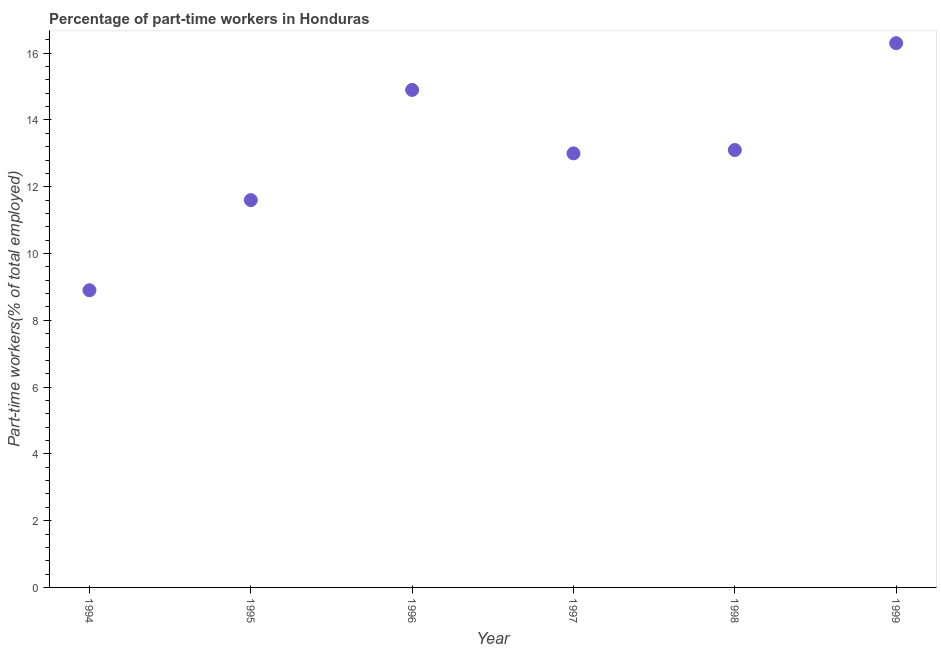What is the percentage of part-time workers in 1994?
Give a very brief answer. 8.9. Across all years, what is the maximum percentage of part-time workers?
Your answer should be very brief. 16.3. Across all years, what is the minimum percentage of part-time workers?
Offer a terse response. 8.9. In which year was the percentage of part-time workers minimum?
Offer a very short reply. 1994. What is the sum of the percentage of part-time workers?
Provide a short and direct response. 77.8. What is the difference between the percentage of part-time workers in 1995 and 1996?
Give a very brief answer. -3.3. What is the average percentage of part-time workers per year?
Offer a very short reply. 12.97. What is the median percentage of part-time workers?
Ensure brevity in your answer.  13.05. In how many years, is the percentage of part-time workers greater than 8.4 %?
Your response must be concise. 6. What is the ratio of the percentage of part-time workers in 1994 to that in 1998?
Keep it short and to the point. 0.68. Is the percentage of part-time workers in 1994 less than that in 1998?
Your answer should be compact. Yes. Is the difference between the percentage of part-time workers in 1995 and 1999 greater than the difference between any two years?
Your answer should be very brief. No. What is the difference between the highest and the second highest percentage of part-time workers?
Offer a terse response. 1.4. Is the sum of the percentage of part-time workers in 1994 and 1996 greater than the maximum percentage of part-time workers across all years?
Keep it short and to the point. Yes. What is the difference between the highest and the lowest percentage of part-time workers?
Keep it short and to the point. 7.4. In how many years, is the percentage of part-time workers greater than the average percentage of part-time workers taken over all years?
Make the answer very short. 4. How many years are there in the graph?
Provide a short and direct response. 6. What is the difference between two consecutive major ticks on the Y-axis?
Your answer should be very brief. 2. Are the values on the major ticks of Y-axis written in scientific E-notation?
Offer a terse response. No. What is the title of the graph?
Your response must be concise. Percentage of part-time workers in Honduras. What is the label or title of the Y-axis?
Offer a very short reply. Part-time workers(% of total employed). What is the Part-time workers(% of total employed) in 1994?
Offer a very short reply. 8.9. What is the Part-time workers(% of total employed) in 1995?
Offer a terse response. 11.6. What is the Part-time workers(% of total employed) in 1996?
Your answer should be compact. 14.9. What is the Part-time workers(% of total employed) in 1997?
Keep it short and to the point. 13. What is the Part-time workers(% of total employed) in 1998?
Ensure brevity in your answer.  13.1. What is the Part-time workers(% of total employed) in 1999?
Your answer should be compact. 16.3. What is the difference between the Part-time workers(% of total employed) in 1994 and 1996?
Offer a terse response. -6. What is the difference between the Part-time workers(% of total employed) in 1994 and 1997?
Keep it short and to the point. -4.1. What is the difference between the Part-time workers(% of total employed) in 1995 and 1996?
Offer a terse response. -3.3. What is the difference between the Part-time workers(% of total employed) in 1995 and 1997?
Keep it short and to the point. -1.4. What is the difference between the Part-time workers(% of total employed) in 1995 and 1999?
Ensure brevity in your answer.  -4.7. What is the difference between the Part-time workers(% of total employed) in 1996 and 1998?
Provide a succinct answer. 1.8. What is the difference between the Part-time workers(% of total employed) in 1997 and 1999?
Your response must be concise. -3.3. What is the ratio of the Part-time workers(% of total employed) in 1994 to that in 1995?
Your answer should be very brief. 0.77. What is the ratio of the Part-time workers(% of total employed) in 1994 to that in 1996?
Your answer should be very brief. 0.6. What is the ratio of the Part-time workers(% of total employed) in 1994 to that in 1997?
Provide a short and direct response. 0.69. What is the ratio of the Part-time workers(% of total employed) in 1994 to that in 1998?
Ensure brevity in your answer.  0.68. What is the ratio of the Part-time workers(% of total employed) in 1994 to that in 1999?
Keep it short and to the point. 0.55. What is the ratio of the Part-time workers(% of total employed) in 1995 to that in 1996?
Keep it short and to the point. 0.78. What is the ratio of the Part-time workers(% of total employed) in 1995 to that in 1997?
Provide a short and direct response. 0.89. What is the ratio of the Part-time workers(% of total employed) in 1995 to that in 1998?
Your answer should be compact. 0.89. What is the ratio of the Part-time workers(% of total employed) in 1995 to that in 1999?
Make the answer very short. 0.71. What is the ratio of the Part-time workers(% of total employed) in 1996 to that in 1997?
Your answer should be very brief. 1.15. What is the ratio of the Part-time workers(% of total employed) in 1996 to that in 1998?
Provide a succinct answer. 1.14. What is the ratio of the Part-time workers(% of total employed) in 1996 to that in 1999?
Your answer should be very brief. 0.91. What is the ratio of the Part-time workers(% of total employed) in 1997 to that in 1999?
Offer a terse response. 0.8. What is the ratio of the Part-time workers(% of total employed) in 1998 to that in 1999?
Ensure brevity in your answer.  0.8. 